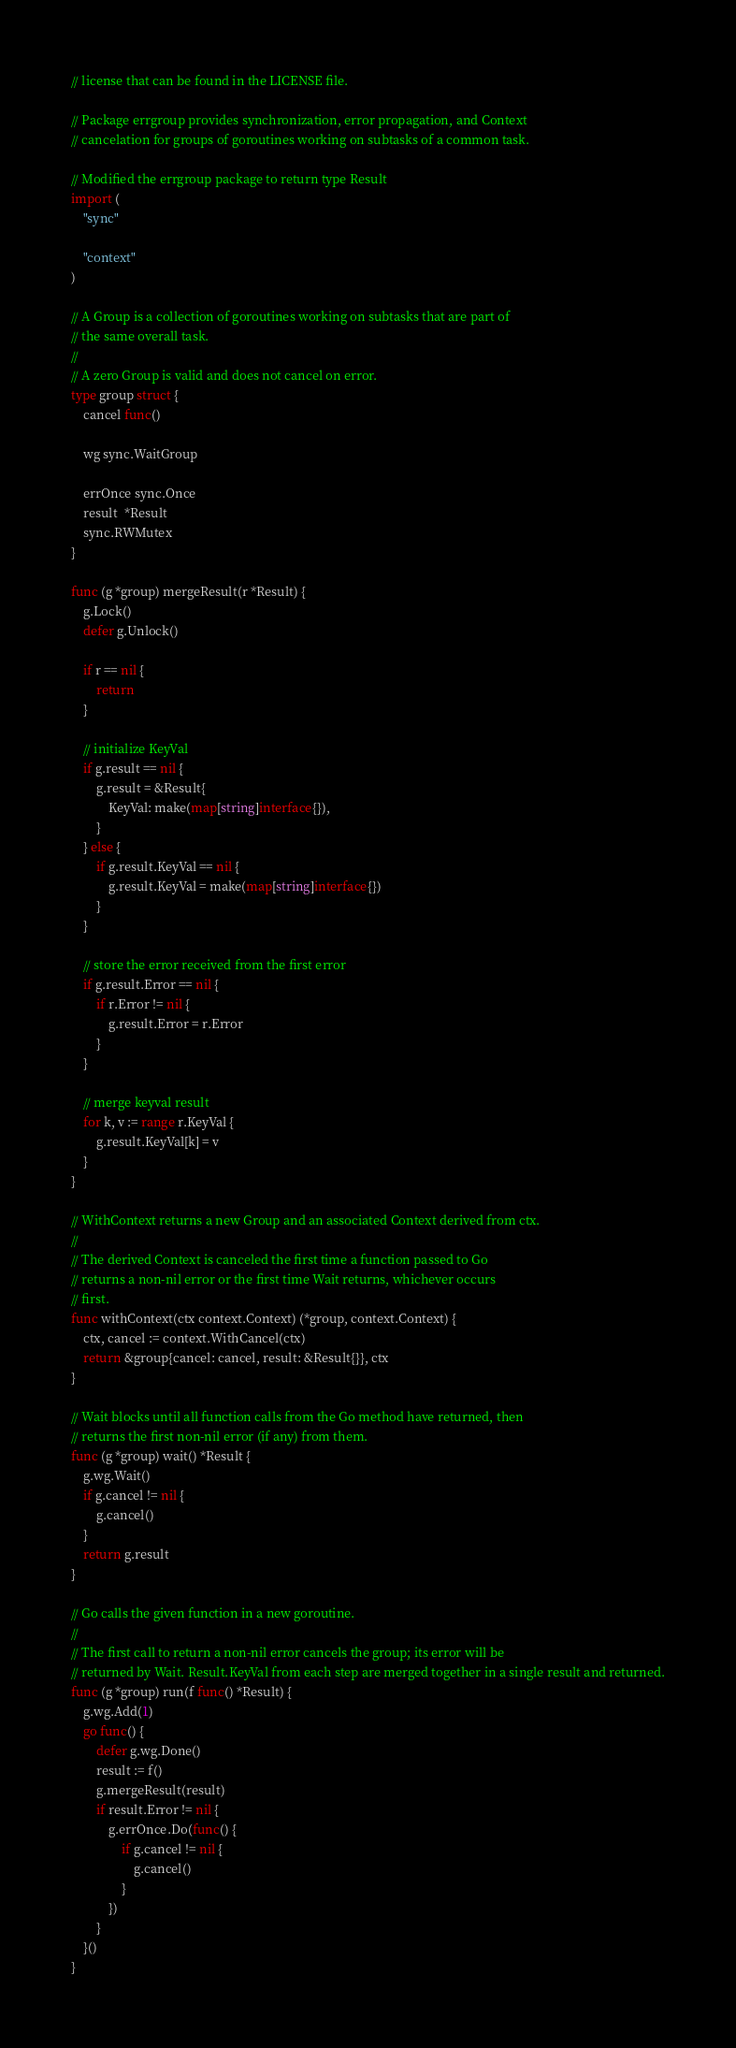<code> <loc_0><loc_0><loc_500><loc_500><_Go_>// license that can be found in the LICENSE file.

// Package errgroup provides synchronization, error propagation, and Context
// cancelation for groups of goroutines working on subtasks of a common task.

// Modified the errgroup package to return type Result
import (
	"sync"

	"context"
)

// A Group is a collection of goroutines working on subtasks that are part of
// the same overall task.
//
// A zero Group is valid and does not cancel on error.
type group struct {
	cancel func()

	wg sync.WaitGroup

	errOnce sync.Once
	result  *Result
	sync.RWMutex
}

func (g *group) mergeResult(r *Result) {
	g.Lock()
	defer g.Unlock()

	if r == nil {
		return
	}

	// initialize KeyVal
	if g.result == nil {
		g.result = &Result{
			KeyVal: make(map[string]interface{}),
		}
	} else {
		if g.result.KeyVal == nil {
			g.result.KeyVal = make(map[string]interface{})
		}
	}

	// store the error received from the first error
	if g.result.Error == nil {
		if r.Error != nil {
			g.result.Error = r.Error
		}
	}

	// merge keyval result
	for k, v := range r.KeyVal {
		g.result.KeyVal[k] = v
	}
}

// WithContext returns a new Group and an associated Context derived from ctx.
//
// The derived Context is canceled the first time a function passed to Go
// returns a non-nil error or the first time Wait returns, whichever occurs
// first.
func withContext(ctx context.Context) (*group, context.Context) {
	ctx, cancel := context.WithCancel(ctx)
	return &group{cancel: cancel, result: &Result{}}, ctx
}

// Wait blocks until all function calls from the Go method have returned, then
// returns the first non-nil error (if any) from them.
func (g *group) wait() *Result {
	g.wg.Wait()
	if g.cancel != nil {
		g.cancel()
	}
	return g.result
}

// Go calls the given function in a new goroutine.
//
// The first call to return a non-nil error cancels the group; its error will be
// returned by Wait. Result.KeyVal from each step are merged together in a single result and returned.
func (g *group) run(f func() *Result) {
	g.wg.Add(1)
	go func() {
		defer g.wg.Done()
		result := f()
		g.mergeResult(result)
		if result.Error != nil {
			g.errOnce.Do(func() {
				if g.cancel != nil {
					g.cancel()
				}
			})
		}
	}()
}
</code> 